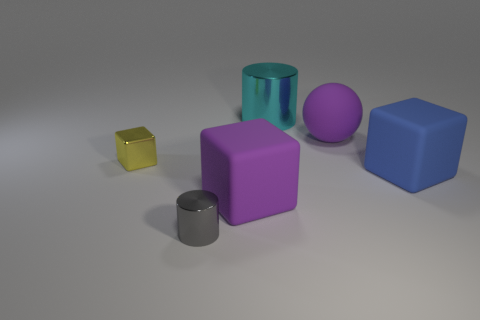Subtract all red cubes. Subtract all gray spheres. How many cubes are left? 3 Subtract all gray spheres. How many brown cylinders are left? 0 Subtract all big cyan matte cylinders. Subtract all big blue rubber cubes. How many objects are left? 5 Add 5 big cylinders. How many big cylinders are left? 6 Add 5 tiny yellow shiny blocks. How many tiny yellow shiny blocks exist? 6 Add 2 large blue rubber cubes. How many objects exist? 8 Subtract all blue blocks. How many blocks are left? 2 Subtract all purple cubes. How many cubes are left? 2 Subtract 1 purple blocks. How many objects are left? 5 Subtract all cylinders. How many objects are left? 4 